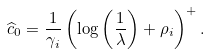<formula> <loc_0><loc_0><loc_500><loc_500>\widehat { c } _ { 0 } = \frac { 1 } { \gamma _ { i } } \left ( \log \left ( \frac { 1 } { \lambda } \right ) + \rho _ { i } \right ) ^ { + } .</formula> 